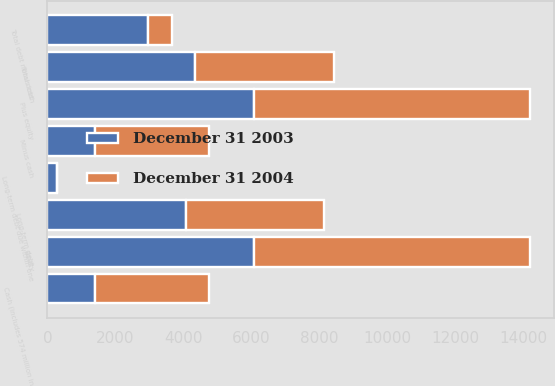Convert chart. <chart><loc_0><loc_0><loc_500><loc_500><stacked_bar_chart><ecel><fcel>Long-term debt due within one<fcel>Long-term debt<fcel>Total debt<fcel>Cash (includes 574 million in<fcel>Equity<fcel>Minus cash<fcel>Total debt minus cash<fcel>Plus equity<nl><fcel>December 31 2004<fcel>16<fcel>4057<fcel>4073<fcel>3369<fcel>8111<fcel>3369<fcel>704<fcel>8111<nl><fcel>December 31 2003<fcel>272<fcel>4085<fcel>4357<fcel>1396<fcel>6075<fcel>1396<fcel>2961<fcel>6075<nl></chart> 